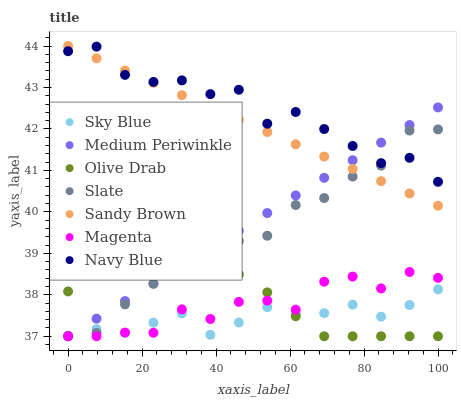Does Sky Blue have the minimum area under the curve?
Answer yes or no. Yes. Does Navy Blue have the maximum area under the curve?
Answer yes or no. Yes. Does Slate have the minimum area under the curve?
Answer yes or no. No. Does Slate have the maximum area under the curve?
Answer yes or no. No. Is Medium Periwinkle the smoothest?
Answer yes or no. Yes. Is Navy Blue the roughest?
Answer yes or no. Yes. Is Slate the smoothest?
Answer yes or no. No. Is Slate the roughest?
Answer yes or no. No. Does Medium Periwinkle have the lowest value?
Answer yes or no. Yes. Does Slate have the lowest value?
Answer yes or no. No. Does Sandy Brown have the highest value?
Answer yes or no. Yes. Does Slate have the highest value?
Answer yes or no. No. Is Olive Drab less than Navy Blue?
Answer yes or no. Yes. Is Slate greater than Magenta?
Answer yes or no. Yes. Does Sky Blue intersect Olive Drab?
Answer yes or no. Yes. Is Sky Blue less than Olive Drab?
Answer yes or no. No. Is Sky Blue greater than Olive Drab?
Answer yes or no. No. Does Olive Drab intersect Navy Blue?
Answer yes or no. No. 